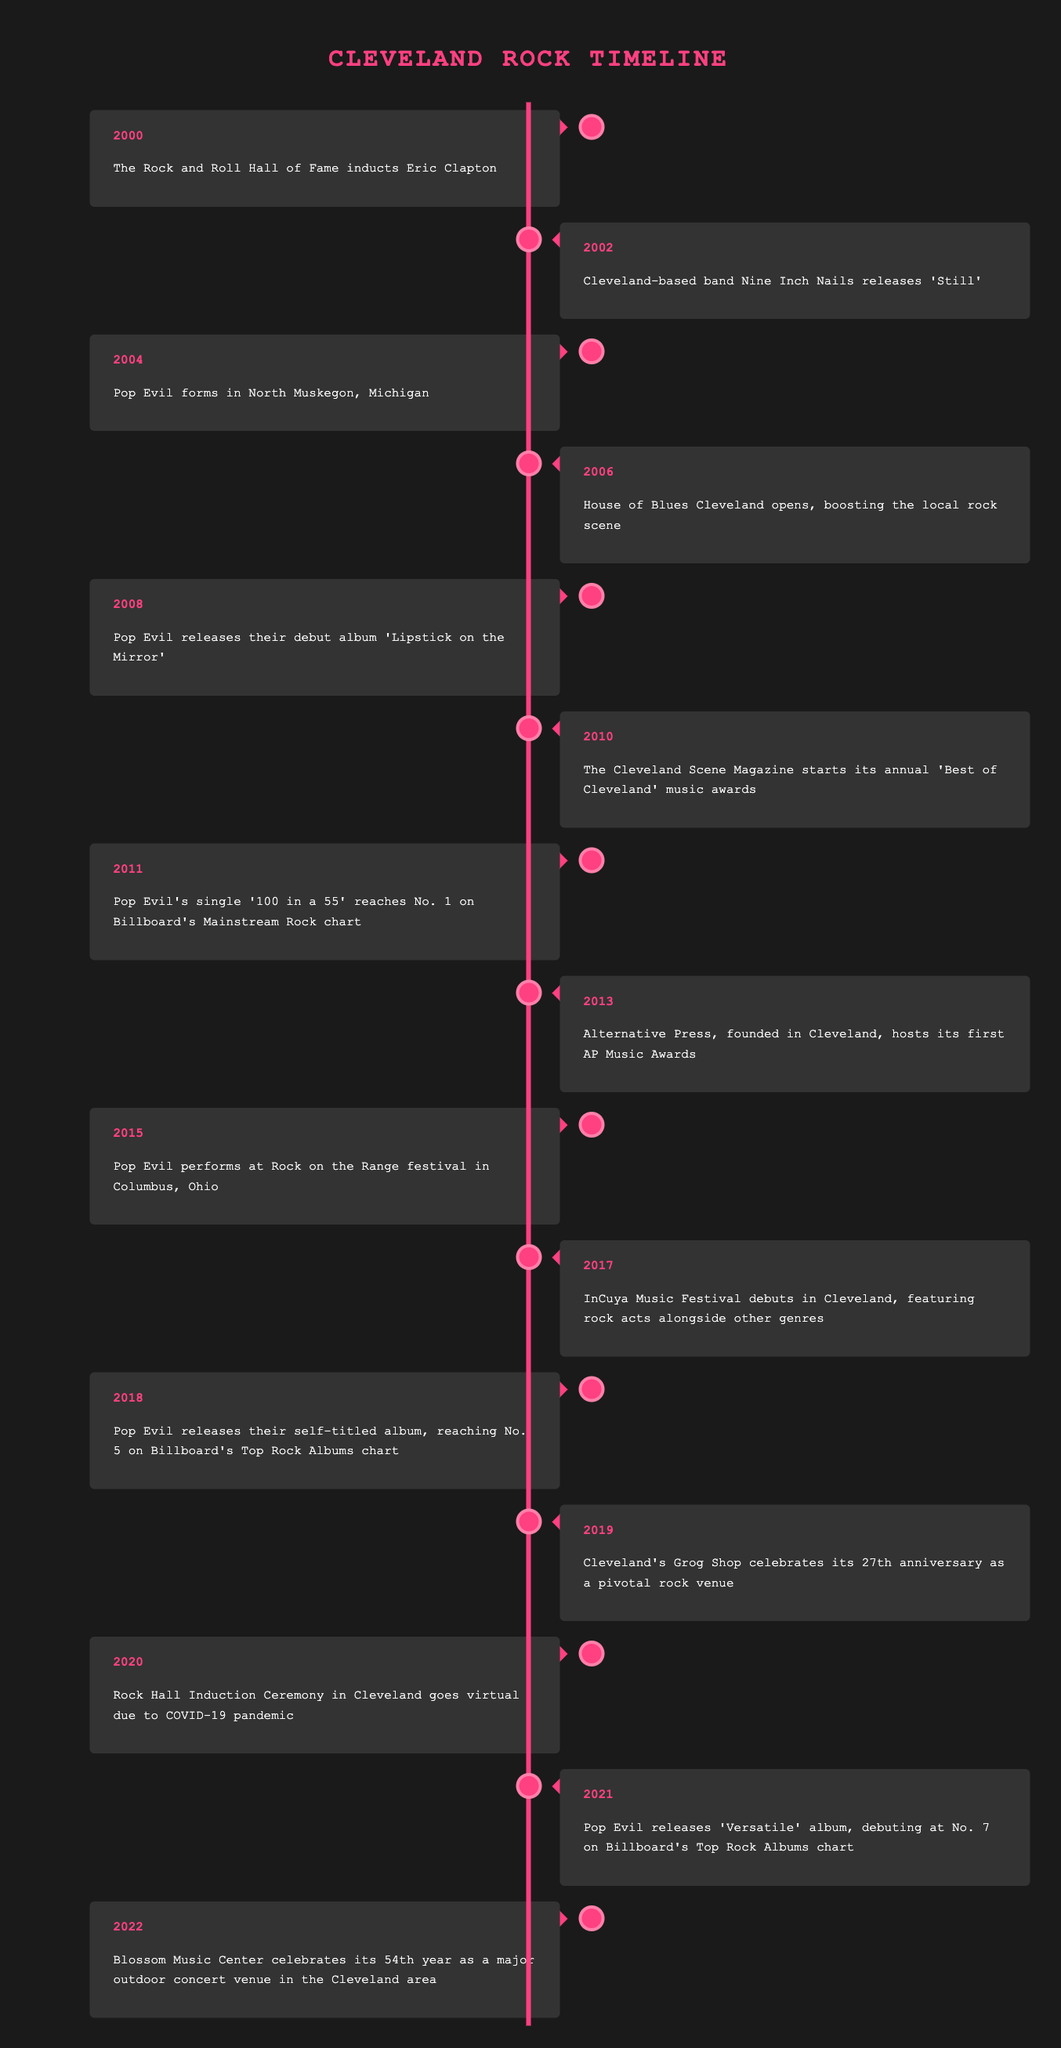What year did Pop Evil release their debut album? The debut album 'Lipstick on the Mirror' was released in 2008, as indicated in the timeline for that year.
Answer: 2008 In which year did the House of Blues Cleveland open? According to the timeline, the House of Blues Cleveland opened in 2006, which is explicitly mentioned next to that year.
Answer: 2006 Did Pop Evil perform at the Rock on the Range festival? Yes, the event is listed in the timeline for 2015, where it states that Pop Evil performed at the Rock on the Range festival in Columbus, Ohio.
Answer: Yes What is the average year of significant events for Pop Evil from their formation to their album releases? Pop Evil formed in 2004 and had significant events in 2008 (debut album), 2011 (single reaching No. 1), 2018 (self-titled album), and 2021 (Versatile album). The average year is calculated as (2004 + 2008 + 2011 + 2018 + 2021) / 5 = 2014.
Answer: 2014 Which event happened in Cleveland related to the Rock and Roll Hall of Fame during the COVID-19 pandemic? In 2020, the Rock Hall Induction Ceremony in Cleveland went virtual due to the pandemic, which is mentioned in that year's entry in the timeline.
Answer: It went virtual What notable event occurred in 2013 regarding Alternative Press in Cleveland? In 2013, the timeline indicates that Alternative Press hosted its first AP Music Awards, showing the emergence of award recognition for rock music in Cleveland.
Answer: Hosted first AP Music Awards How many years apart were Pop Evil's self-titled album release and the release of 'Versatile'? Pop Evil released their self-titled album in 2018 and 'Versatile' in 2021. The year difference is calculated as 2021 - 2018 = 3 years.
Answer: 3 years Was there a notable event in 2019 related to a local venue? Yes, the timeline indicates that Cleveland's Grog Shop celebrated its 27th anniversary as a pivotal rock venue in 2019.
Answer: Yes What major festival debuted in Cleveland in 2017 and featured various genres? In 2017, the InCuya Music Festival debuted in Cleveland, marking an event that showcased rock acts alongside other music genres.
Answer: InCuya Music Festival What are the two key Pop Evil albums listed in the timeline? The two key albums mentioned are 'Lipstick on the Mirror' released in 2008 and the self-titled album released in 2018.
Answer: Lipstick on the Mirror and self-titled album 